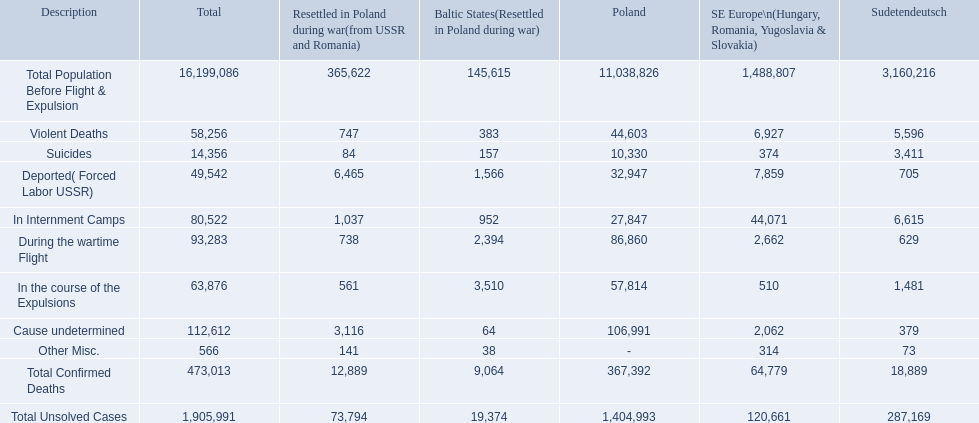What were the total number of confirmed deaths? 473,013. Of these, how many were violent? 58,256. 